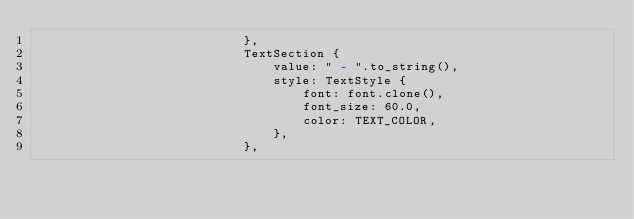<code> <loc_0><loc_0><loc_500><loc_500><_Rust_>                            },
                            TextSection {
                                value: " - ".to_string(),
                                style: TextStyle {
                                    font: font.clone(),
                                    font_size: 60.0,
                                    color: TEXT_COLOR,
                                },
                            },</code> 